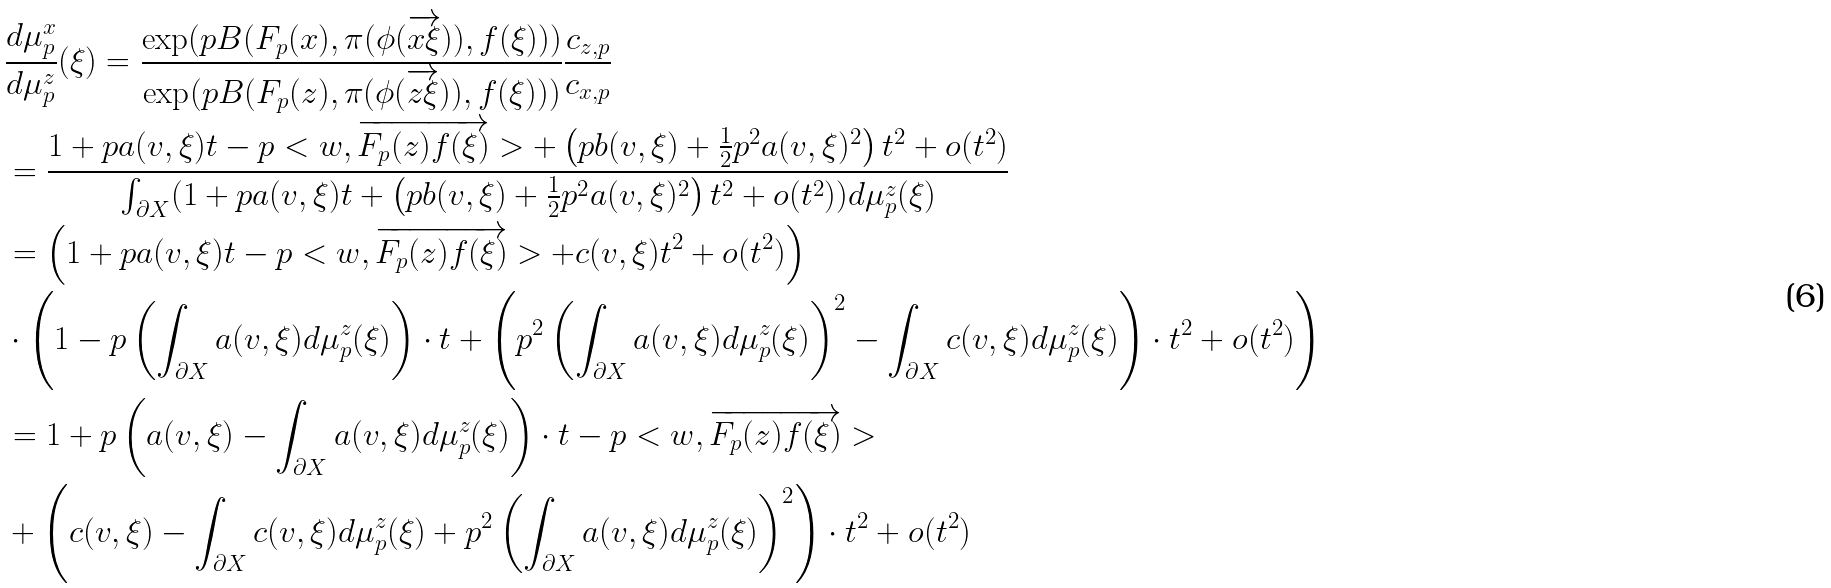Convert formula to latex. <formula><loc_0><loc_0><loc_500><loc_500>& \frac { d \mu ^ { x } _ { p } } { d \mu ^ { z } _ { p } } ( \xi ) = \frac { \exp ( p B ( F _ { p } ( x ) , \pi ( \phi ( \overrightarrow { x \xi } ) ) , f ( \xi ) ) ) } { \exp ( p B ( F _ { p } ( z ) , \pi ( \phi ( \overrightarrow { z \xi } ) ) , f ( \xi ) ) ) } \frac { c _ { z , p } } { c _ { x , p } } \\ & = \frac { 1 + p a ( v , \xi ) t - p < w , \overrightarrow { F _ { p } ( z ) f ( \xi ) } > + \left ( p b ( v , \xi ) + \frac { 1 } { 2 } p ^ { 2 } a ( v , \xi ) ^ { 2 } \right ) t ^ { 2 } + o ( t ^ { 2 } ) } { \int _ { \partial X } ( 1 + p a ( v , \xi ) t + \left ( p b ( v , \xi ) + \frac { 1 } { 2 } p ^ { 2 } a ( v , \xi ) ^ { 2 } \right ) t ^ { 2 } + o ( t ^ { 2 } ) ) d \mu ^ { z } _ { p } ( \xi ) } \\ & = \left ( 1 + p a ( v , \xi ) t - p < w , \overrightarrow { F _ { p } ( z ) f ( \xi ) } > + c ( v , \xi ) t ^ { 2 } + o ( t ^ { 2 } ) \right ) \\ & \cdot \left ( 1 - p \left ( \int _ { \partial X } a ( v , \xi ) d \mu ^ { z } _ { p } ( \xi ) \right ) \cdot t + \left ( p ^ { 2 } \left ( \int _ { \partial X } a ( v , \xi ) d \mu ^ { z } _ { p } ( \xi ) \right ) ^ { 2 } - \int _ { \partial X } c ( v , \xi ) d \mu ^ { z } _ { p } ( \xi ) \right ) \cdot t ^ { 2 } + o ( t ^ { 2 } ) \right ) \\ & = 1 + p \left ( a ( v , \xi ) - \int _ { \partial X } a ( v , \xi ) d \mu ^ { z } _ { p } ( \xi ) \right ) \cdot t - p < w , \overrightarrow { F _ { p } ( z ) f ( \xi ) } > \\ & + \left ( c ( v , \xi ) - \int _ { \partial X } c ( v , \xi ) d \mu ^ { z } _ { p } ( \xi ) + p ^ { 2 } \left ( \int _ { \partial X } a ( v , \xi ) d \mu ^ { z } _ { p } ( \xi ) \right ) ^ { 2 } \right ) \cdot t ^ { 2 } + o ( t ^ { 2 } ) \\</formula> 